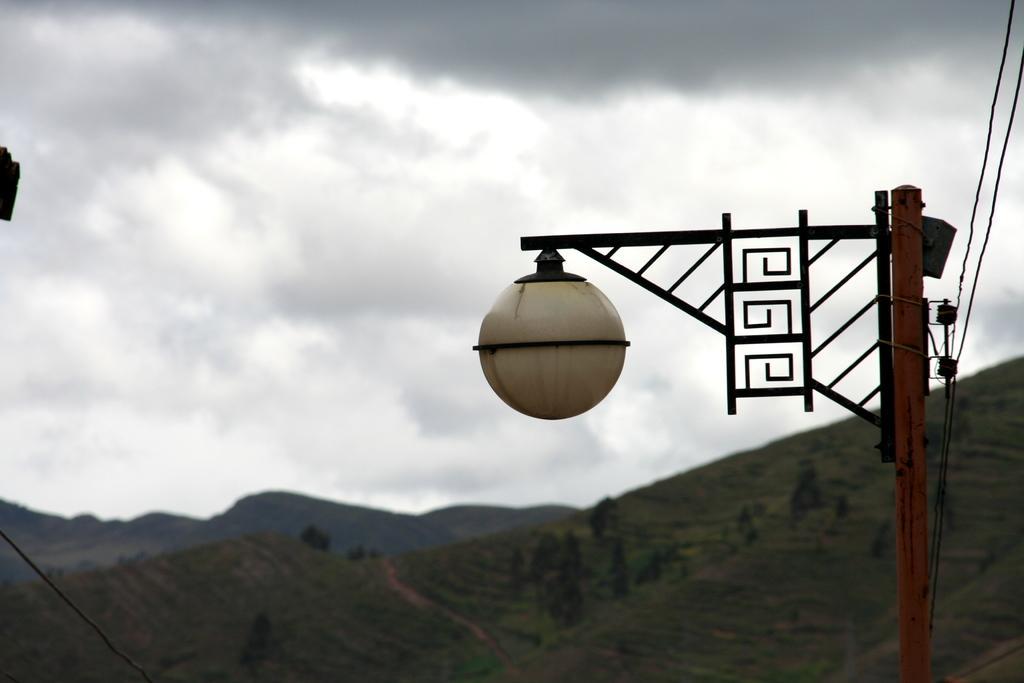Please provide a concise description of this image. As we can see in the image there are hills, light, sky and clouds. 